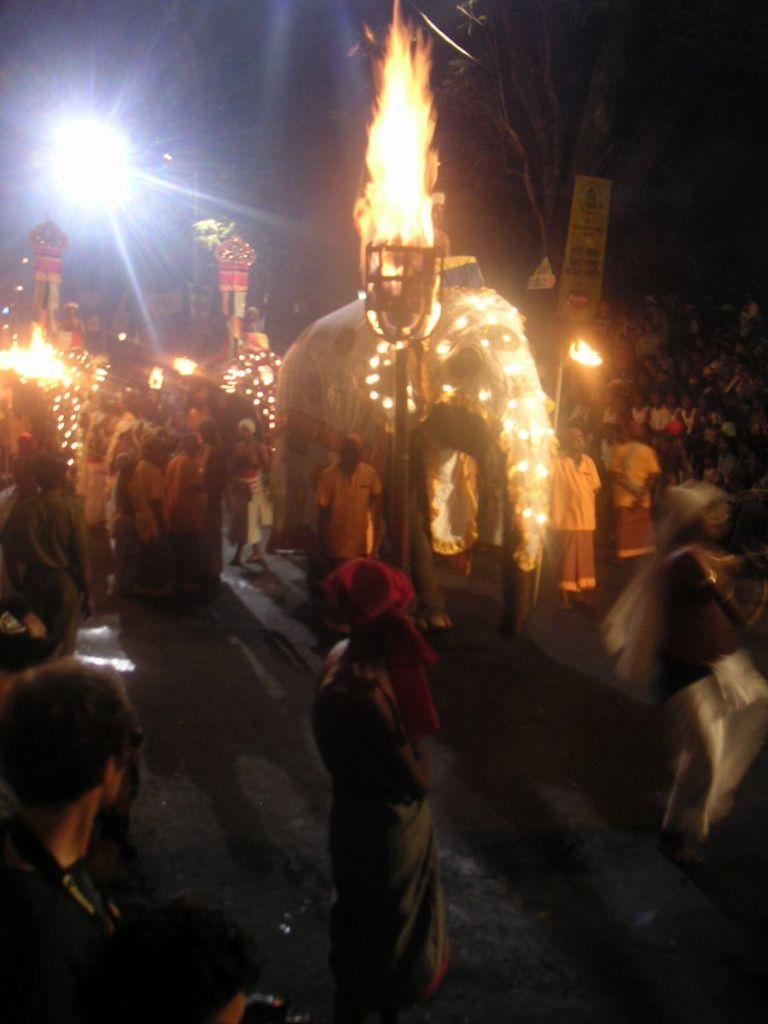What is the main feature of the image? There is a road in the image. How many people can be seen in the image? There are many people present in the image. What kind of animals are in the image? There are elephants decorated with lights in the image. What are some people doing in the image? Some people are catching fire pots in the image. Can you describe the lighting in the image? There is a light visible in the image. How many toes can be seen on the elephants in the image? Elephants do not have toes; they have hooves. Therefore, there are no toes visible on the elephants in the image. What type of thrill can be experienced by the people in the image? The provided facts do not mention any specific thrill or excitement experienced by the people in the image. --- Facts: 1. There is a river in the image. 2. There are boats on the river. 3. There are people fishing in the image. 4. There are trees on the riverbank. 5. The sky is visible in the image. Absurd Topics: piano, dance, robot Conversation: What is the main feature of the image? There is a river in the image. What is on the river? There are there any objects or activities taking place on the river? What are some people doing in the image? There are people fishing in the image. What type of vegetation is present in the image? There are trees on the riverbank. What is visible in the background of the image? The sky is visible in the image. Reasoning: Let's think step by step in order to produce the conversation. We start by identifying the main feature of the image, which is the river. Then, we mention the boats on the river and the people fishing, which are both activities related to the river. Next, we describe the vegetation present in the image, specifically the trees on the riverbank. Finally, we mention the sky visible in the background of the image. Absurd Question/Answer: Can you hear a piano playing in the background of the image? There is no mention of a piano in the image. --- Facts: 1. There is a car in the image. 12. The car is red. 123. The car has four wheels. 123456789012345678901234567890123456789012345678901234567890123456789012345678901234 